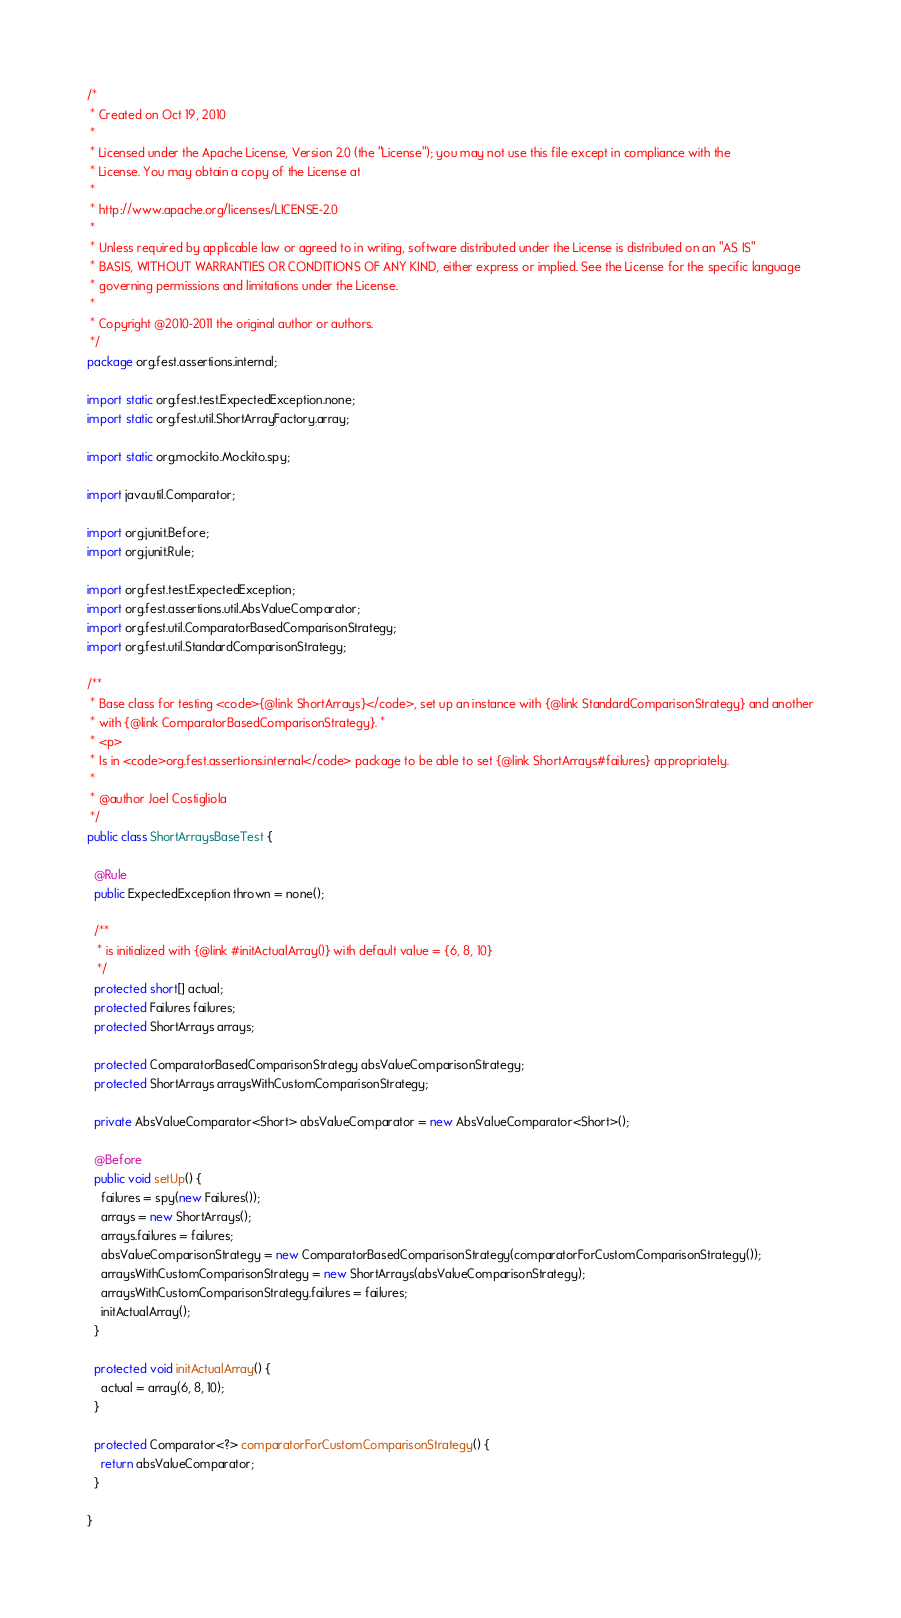Convert code to text. <code><loc_0><loc_0><loc_500><loc_500><_Java_>/*
 * Created on Oct 19, 2010
 * 
 * Licensed under the Apache License, Version 2.0 (the "License"); you may not use this file except in compliance with the
 * License. You may obtain a copy of the License at
 * 
 * http://www.apache.org/licenses/LICENSE-2.0
 * 
 * Unless required by applicable law or agreed to in writing, software distributed under the License is distributed on an "AS IS"
 * BASIS, WITHOUT WARRANTIES OR CONDITIONS OF ANY KIND, either express or implied. See the License for the specific language
 * governing permissions and limitations under the License.
 * 
 * Copyright @2010-2011 the original author or authors.
 */
package org.fest.assertions.internal;

import static org.fest.test.ExpectedException.none;
import static org.fest.util.ShortArrayFactory.array;

import static org.mockito.Mockito.spy;

import java.util.Comparator;

import org.junit.Before;
import org.junit.Rule;

import org.fest.test.ExpectedException;
import org.fest.assertions.util.AbsValueComparator;
import org.fest.util.ComparatorBasedComparisonStrategy;
import org.fest.util.StandardComparisonStrategy;

/**
 * Base class for testing <code>{@link ShortArrays}</code>, set up an instance with {@link StandardComparisonStrategy} and another
 * with {@link ComparatorBasedComparisonStrategy}. *
 * <p>
 * Is in <code>org.fest.assertions.internal</code> package to be able to set {@link ShortArrays#failures} appropriately.
 * 
 * @author Joel Costigliola
 */
public class ShortArraysBaseTest {

  @Rule
  public ExpectedException thrown = none();

  /**
   * is initialized with {@link #initActualArray()} with default value = {6, 8, 10}
   */
  protected short[] actual;
  protected Failures failures;
  protected ShortArrays arrays;

  protected ComparatorBasedComparisonStrategy absValueComparisonStrategy;
  protected ShortArrays arraysWithCustomComparisonStrategy;

  private AbsValueComparator<Short> absValueComparator = new AbsValueComparator<Short>();

  @Before
  public void setUp() {
    failures = spy(new Failures());
    arrays = new ShortArrays();
    arrays.failures = failures;
    absValueComparisonStrategy = new ComparatorBasedComparisonStrategy(comparatorForCustomComparisonStrategy());
    arraysWithCustomComparisonStrategy = new ShortArrays(absValueComparisonStrategy);
    arraysWithCustomComparisonStrategy.failures = failures;
    initActualArray();
  }

  protected void initActualArray() {
    actual = array(6, 8, 10);
  }

  protected Comparator<?> comparatorForCustomComparisonStrategy() {
    return absValueComparator;
  }

}</code> 